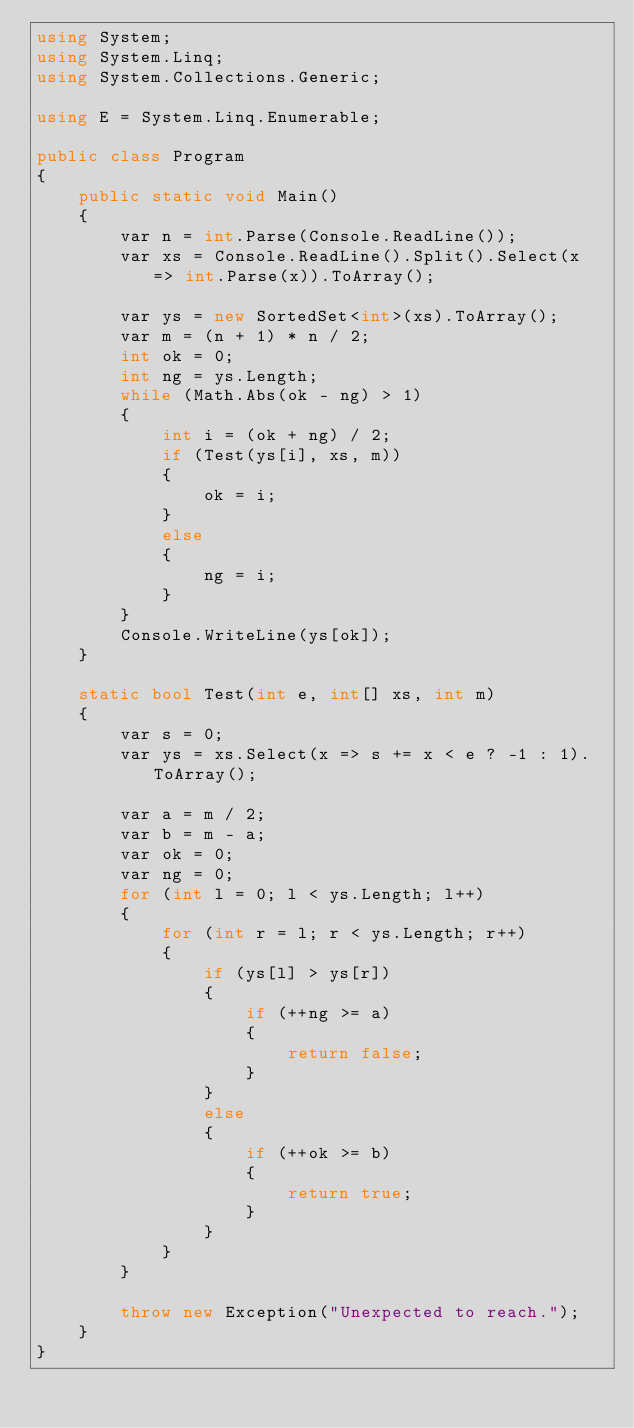<code> <loc_0><loc_0><loc_500><loc_500><_C#_>using System;
using System.Linq;
using System.Collections.Generic;

using E = System.Linq.Enumerable;

public class Program
{
    public static void Main()
    {
        var n = int.Parse(Console.ReadLine());
        var xs = Console.ReadLine().Split().Select(x => int.Parse(x)).ToArray();

        var ys = new SortedSet<int>(xs).ToArray();
        var m = (n + 1) * n / 2;
        int ok = 0;
        int ng = ys.Length;
        while (Math.Abs(ok - ng) > 1)
        {
            int i = (ok + ng) / 2;
            if (Test(ys[i], xs, m))
            {
                ok = i;
            }
            else
            {
                ng = i;
            }
        }
        Console.WriteLine(ys[ok]);
    }

    static bool Test(int e, int[] xs, int m)
    {
        var s = 0;
        var ys = xs.Select(x => s += x < e ? -1 : 1).ToArray();
        
        var a = m / 2;
        var b = m - a;
        var ok = 0;
        var ng = 0;
        for (int l = 0; l < ys.Length; l++)
        {
            for (int r = l; r < ys.Length; r++)
            {
                if (ys[l] > ys[r])
                {
                    if (++ng >= a)
                    {
                        return false;
                    }
                }
                else
                {
                    if (++ok >= b)
                    {
                        return true;
                    }
                }
            }
        }

        throw new Exception("Unexpected to reach.");
    }
}</code> 